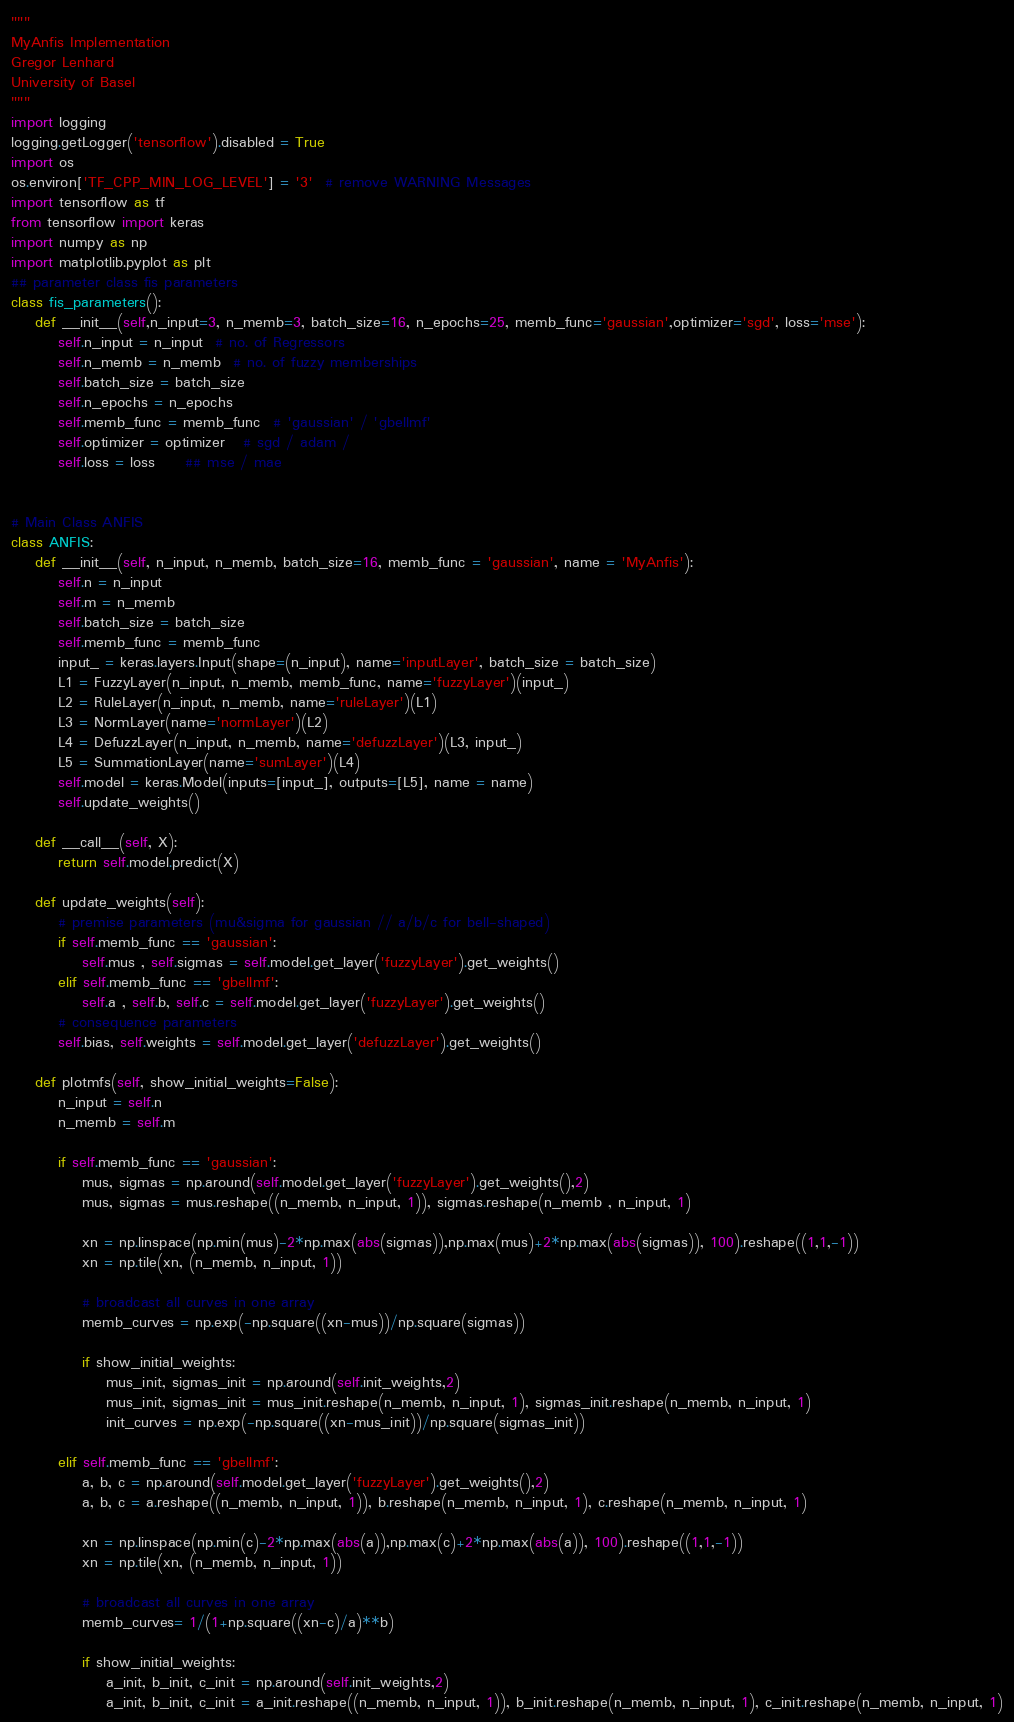<code> <loc_0><loc_0><loc_500><loc_500><_Python_>"""
MyAnfis Implementation
Gregor Lenhard
University of Basel
"""
import logging
logging.getLogger('tensorflow').disabled = True
import os
os.environ['TF_CPP_MIN_LOG_LEVEL'] = '3'  # remove WARNING Messages
import tensorflow as tf
from tensorflow import keras
import numpy as np
import matplotlib.pyplot as plt
## parameter class fis parameters
class fis_parameters():
    def __init__(self,n_input=3, n_memb=3, batch_size=16, n_epochs=25, memb_func='gaussian',optimizer='sgd', loss='mse'):
        self.n_input = n_input  # no. of Regressors
        self.n_memb = n_memb  # no. of fuzzy memberships
        self.batch_size = batch_size
        self.n_epochs = n_epochs
        self.memb_func = memb_func  # 'gaussian' / 'gbellmf'
        self.optimizer = optimizer   # sgd / adam /
        self.loss = loss     ## mse / mae


# Main Class ANFIS
class ANFIS:
    def __init__(self, n_input, n_memb, batch_size=16, memb_func = 'gaussian', name = 'MyAnfis'):
        self.n = n_input
        self.m = n_memb
        self.batch_size = batch_size
        self.memb_func = memb_func
        input_ = keras.layers.Input(shape=(n_input), name='inputLayer', batch_size = batch_size)
        L1 = FuzzyLayer(n_input, n_memb, memb_func, name='fuzzyLayer')(input_)
        L2 = RuleLayer(n_input, n_memb, name='ruleLayer')(L1)
        L3 = NormLayer(name='normLayer')(L2)
        L4 = DefuzzLayer(n_input, n_memb, name='defuzzLayer')(L3, input_)
        L5 = SummationLayer(name='sumLayer')(L4)
        self.model = keras.Model(inputs=[input_], outputs=[L5], name = name)
        self.update_weights()

    def __call__(self, X):
        return self.model.predict(X)

    def update_weights(self):
        # premise parameters (mu&sigma for gaussian // a/b/c for bell-shaped)
        if self.memb_func == 'gaussian':
            self.mus , self.sigmas = self.model.get_layer('fuzzyLayer').get_weights()
        elif self.memb_func == 'gbellmf':
            self.a , self.b, self.c = self.model.get_layer('fuzzyLayer').get_weights()
        # consequence parameters
        self.bias, self.weights = self.model.get_layer('defuzzLayer').get_weights()

    def plotmfs(self, show_initial_weights=False):
        n_input = self.n
        n_memb = self.m

        if self.memb_func == 'gaussian':
            mus, sigmas = np.around(self.model.get_layer('fuzzyLayer').get_weights(),2)
            mus, sigmas = mus.reshape((n_memb, n_input, 1)), sigmas.reshape(n_memb , n_input, 1)

            xn = np.linspace(np.min(mus)-2*np.max(abs(sigmas)),np.max(mus)+2*np.max(abs(sigmas)), 100).reshape((1,1,-1))
            xn = np.tile(xn, (n_memb, n_input, 1))

            # broadcast all curves in one array
            memb_curves = np.exp(-np.square((xn-mus))/np.square(sigmas))

            if show_initial_weights:
                mus_init, sigmas_init = np.around(self.init_weights,2)
                mus_init, sigmas_init = mus_init.reshape(n_memb, n_input, 1), sigmas_init.reshape(n_memb, n_input, 1)
                init_curves = np.exp(-np.square((xn-mus_init))/np.square(sigmas_init))

        elif self.memb_func == 'gbellmf':
            a, b, c = np.around(self.model.get_layer('fuzzyLayer').get_weights(),2)
            a, b, c = a.reshape((n_memb, n_input, 1)), b.reshape(n_memb, n_input, 1), c.reshape(n_memb, n_input, 1)

            xn = np.linspace(np.min(c)-2*np.max(abs(a)),np.max(c)+2*np.max(abs(a)), 100).reshape((1,1,-1))
            xn = np.tile(xn, (n_memb, n_input, 1))

            # broadcast all curves in one array
            memb_curves= 1/(1+np.square((xn-c)/a)**b)

            if show_initial_weights:
                a_init, b_init, c_init = np.around(self.init_weights,2)
                a_init, b_init, c_init = a_init.reshape((n_memb, n_input, 1)), b_init.reshape(n_memb, n_input, 1), c_init.reshape(n_memb, n_input, 1)</code> 